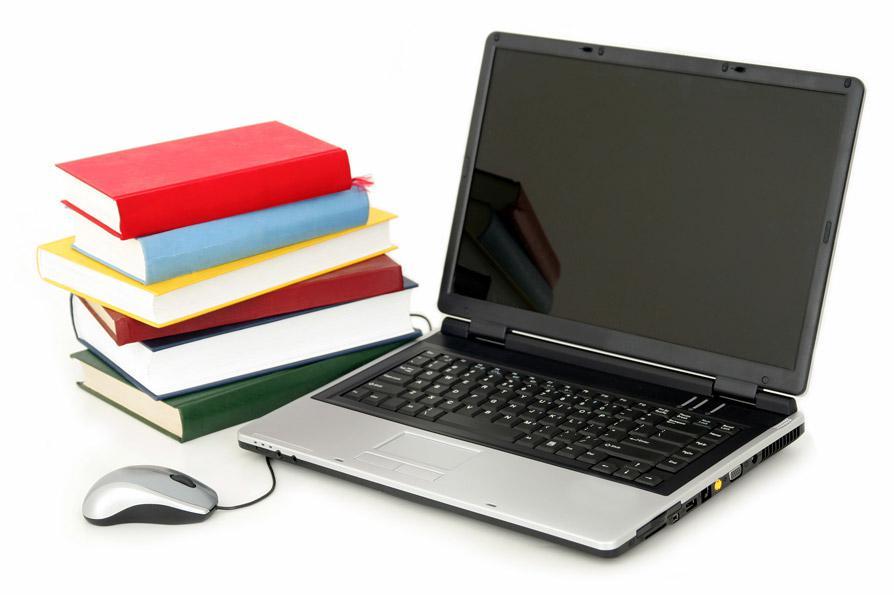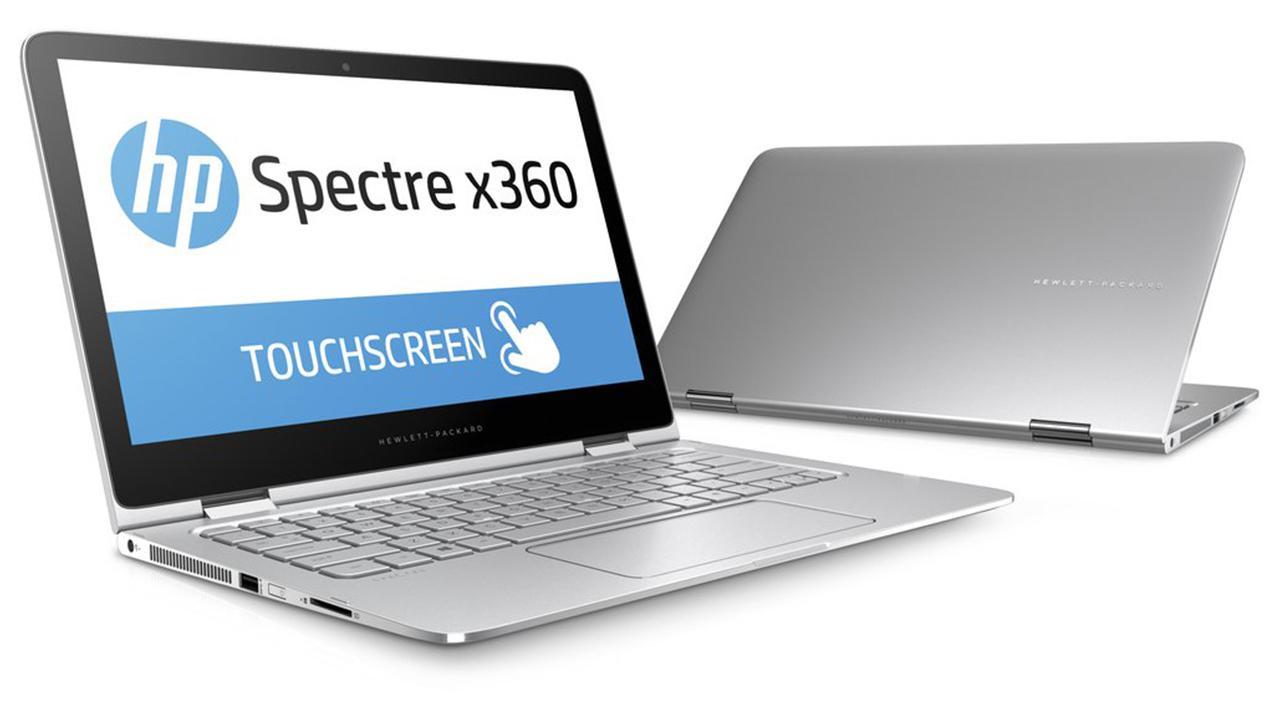The first image is the image on the left, the second image is the image on the right. Given the left and right images, does the statement "There is one computer mouse in these." hold true? Answer yes or no. Yes. The first image is the image on the left, the second image is the image on the right. For the images shown, is this caption "There are 3 or more books being displayed with laptops." true? Answer yes or no. Yes. 